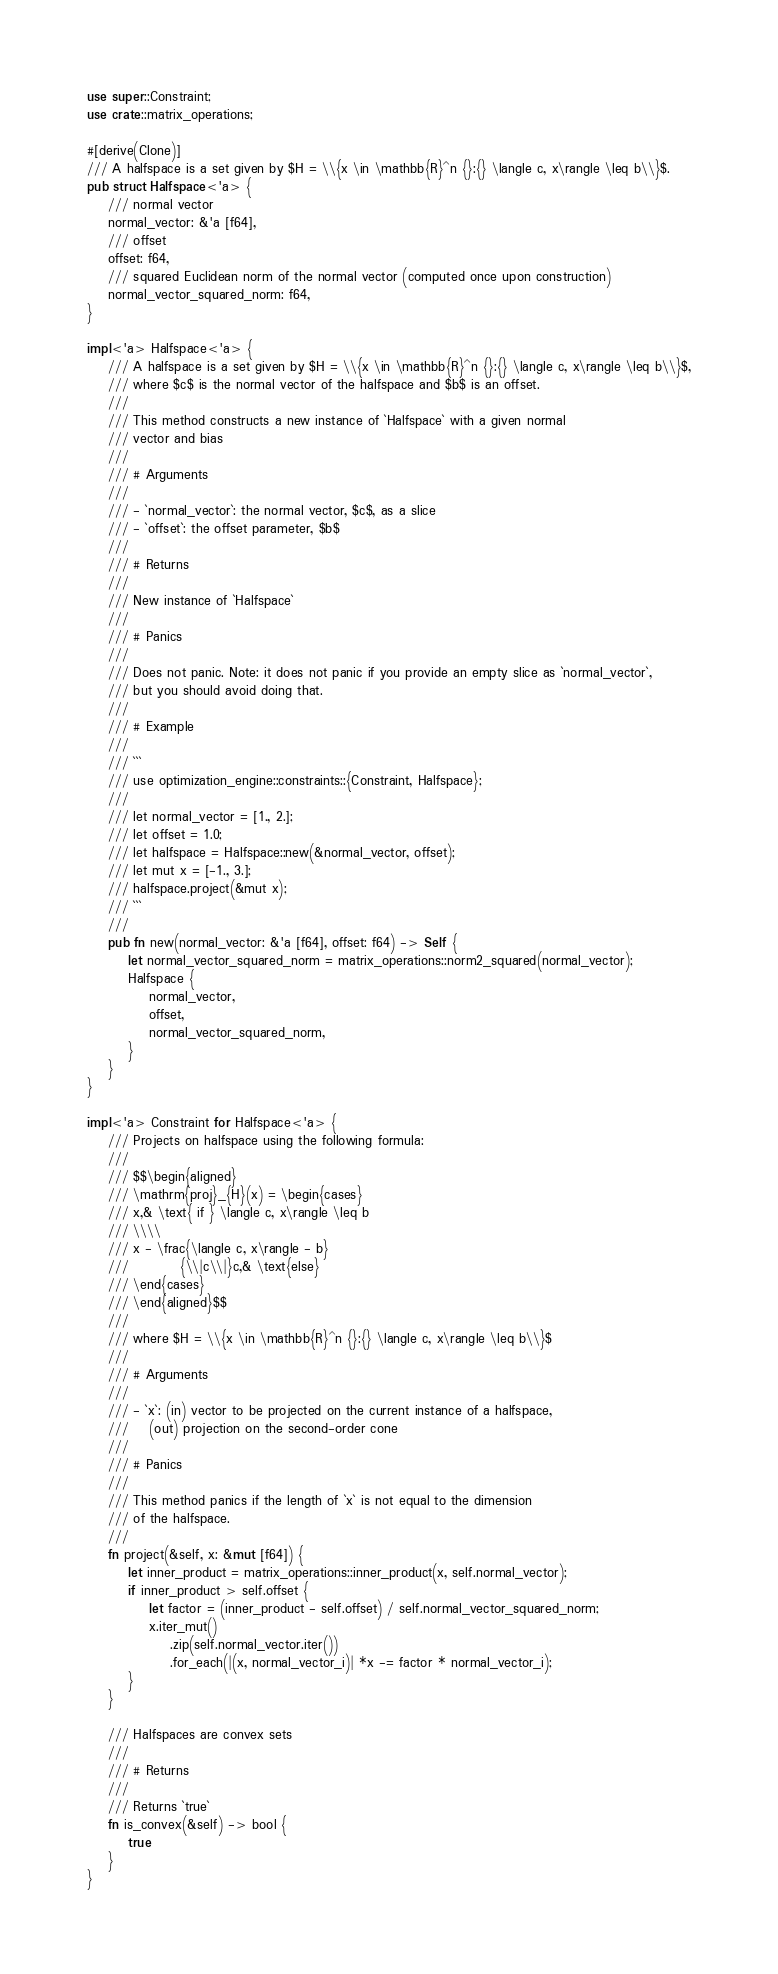Convert code to text. <code><loc_0><loc_0><loc_500><loc_500><_Rust_>use super::Constraint;
use crate::matrix_operations;

#[derive(Clone)]
/// A halfspace is a set given by $H = \\{x \in \mathbb{R}^n {}:{} \langle c, x\rangle \leq b\\}$.
pub struct Halfspace<'a> {
    /// normal vector
    normal_vector: &'a [f64],
    /// offset
    offset: f64,
    /// squared Euclidean norm of the normal vector (computed once upon construction)
    normal_vector_squared_norm: f64,
}

impl<'a> Halfspace<'a> {
    /// A halfspace is a set given by $H = \\{x \in \mathbb{R}^n {}:{} \langle c, x\rangle \leq b\\}$,
    /// where $c$ is the normal vector of the halfspace and $b$ is an offset.
    ///
    /// This method constructs a new instance of `Halfspace` with a given normal
    /// vector and bias
    ///
    /// # Arguments
    ///
    /// - `normal_vector`: the normal vector, $c$, as a slice
    /// - `offset`: the offset parameter, $b$
    ///
    /// # Returns
    ///
    /// New instance of `Halfspace`
    ///
    /// # Panics
    ///
    /// Does not panic. Note: it does not panic if you provide an empty slice as `normal_vector`,
    /// but you should avoid doing that.
    ///
    /// # Example
    ///
    /// ```
    /// use optimization_engine::constraints::{Constraint, Halfspace};
    ///
    /// let normal_vector = [1., 2.];
    /// let offset = 1.0;
    /// let halfspace = Halfspace::new(&normal_vector, offset);
    /// let mut x = [-1., 3.];
    /// halfspace.project(&mut x);
    /// ```
    ///
    pub fn new(normal_vector: &'a [f64], offset: f64) -> Self {
        let normal_vector_squared_norm = matrix_operations::norm2_squared(normal_vector);
        Halfspace {
            normal_vector,
            offset,
            normal_vector_squared_norm,
        }
    }
}

impl<'a> Constraint for Halfspace<'a> {
    /// Projects on halfspace using the following formula:
    ///
    /// $$\begin{aligned}
    /// \mathrm{proj}_{H}(x) = \begin{cases}
    /// x,& \text{ if } \langle c, x\rangle \leq b
    /// \\\\
    /// x - \frac{\langle c, x\rangle - b}
    ///          {\\|c\\|}c,& \text{else}
    /// \end{cases}
    /// \end{aligned}$$
    ///
    /// where $H = \\{x \in \mathbb{R}^n {}:{} \langle c, x\rangle \leq b\\}$
    ///
    /// # Arguments
    ///
    /// - `x`: (in) vector to be projected on the current instance of a halfspace,
    ///    (out) projection on the second-order cone
    ///
    /// # Panics
    ///
    /// This method panics if the length of `x` is not equal to the dimension
    /// of the halfspace.
    ///
    fn project(&self, x: &mut [f64]) {
        let inner_product = matrix_operations::inner_product(x, self.normal_vector);
        if inner_product > self.offset {
            let factor = (inner_product - self.offset) / self.normal_vector_squared_norm;
            x.iter_mut()
                .zip(self.normal_vector.iter())
                .for_each(|(x, normal_vector_i)| *x -= factor * normal_vector_i);
        }
    }

    /// Halfspaces are convex sets
    ///
    /// # Returns
    ///
    /// Returns `true`
    fn is_convex(&self) -> bool {
        true
    }
}
</code> 